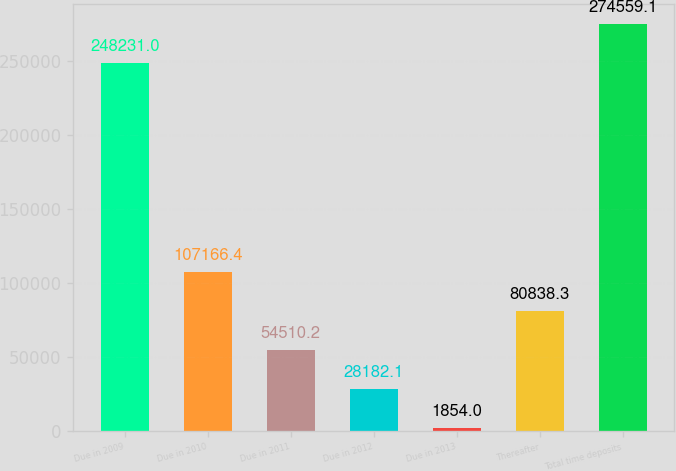Convert chart to OTSL. <chart><loc_0><loc_0><loc_500><loc_500><bar_chart><fcel>Due in 2009<fcel>Due in 2010<fcel>Due in 2011<fcel>Due in 2012<fcel>Due in 2013<fcel>Thereafter<fcel>Total time deposits<nl><fcel>248231<fcel>107166<fcel>54510.2<fcel>28182.1<fcel>1854<fcel>80838.3<fcel>274559<nl></chart> 